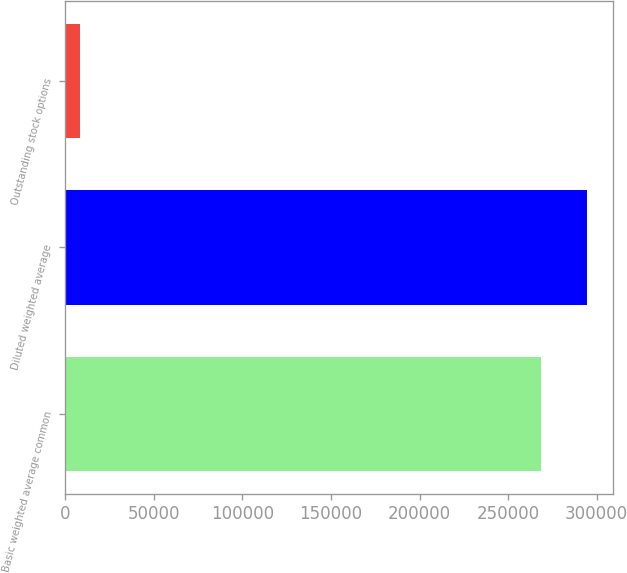<chart> <loc_0><loc_0><loc_500><loc_500><bar_chart><fcel>Basic weighted average common<fcel>Diluted weighted average<fcel>Outstanding stock options<nl><fcel>268704<fcel>294730<fcel>8445<nl></chart> 